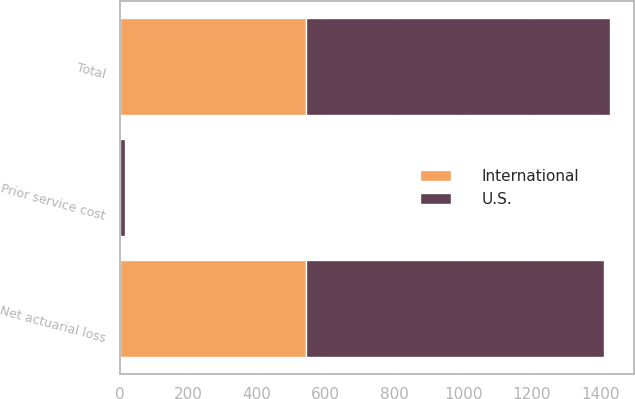Convert chart to OTSL. <chart><loc_0><loc_0><loc_500><loc_500><stacked_bar_chart><ecel><fcel>Net actuarial loss<fcel>Prior service cost<fcel>Total<nl><fcel>U.S.<fcel>869.8<fcel>13.7<fcel>883.5<nl><fcel>International<fcel>541.8<fcel>1.4<fcel>543.6<nl></chart> 